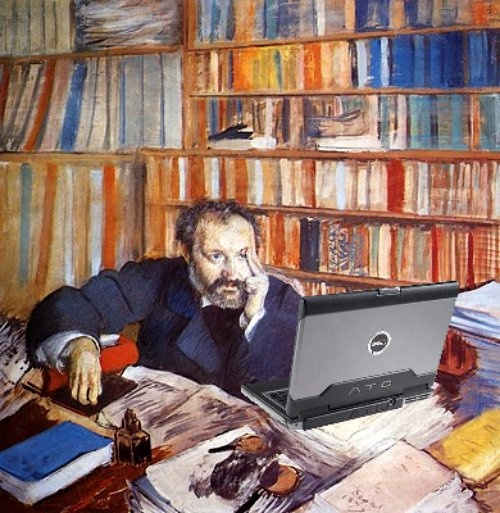Describe the objects in this image and their specific colors. I can see book in gray, darkgray, and lightgray tones, people in gray, black, and lightgray tones, laptop in gray, darkgray, and black tones, book in gray, blue, navy, and lightgray tones, and book in gray, tan, and olive tones in this image. 